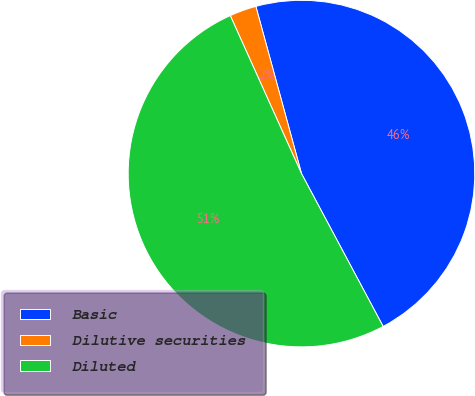Convert chart to OTSL. <chart><loc_0><loc_0><loc_500><loc_500><pie_chart><fcel>Basic<fcel>Dilutive securities<fcel>Diluted<nl><fcel>46.43%<fcel>2.5%<fcel>51.07%<nl></chart> 